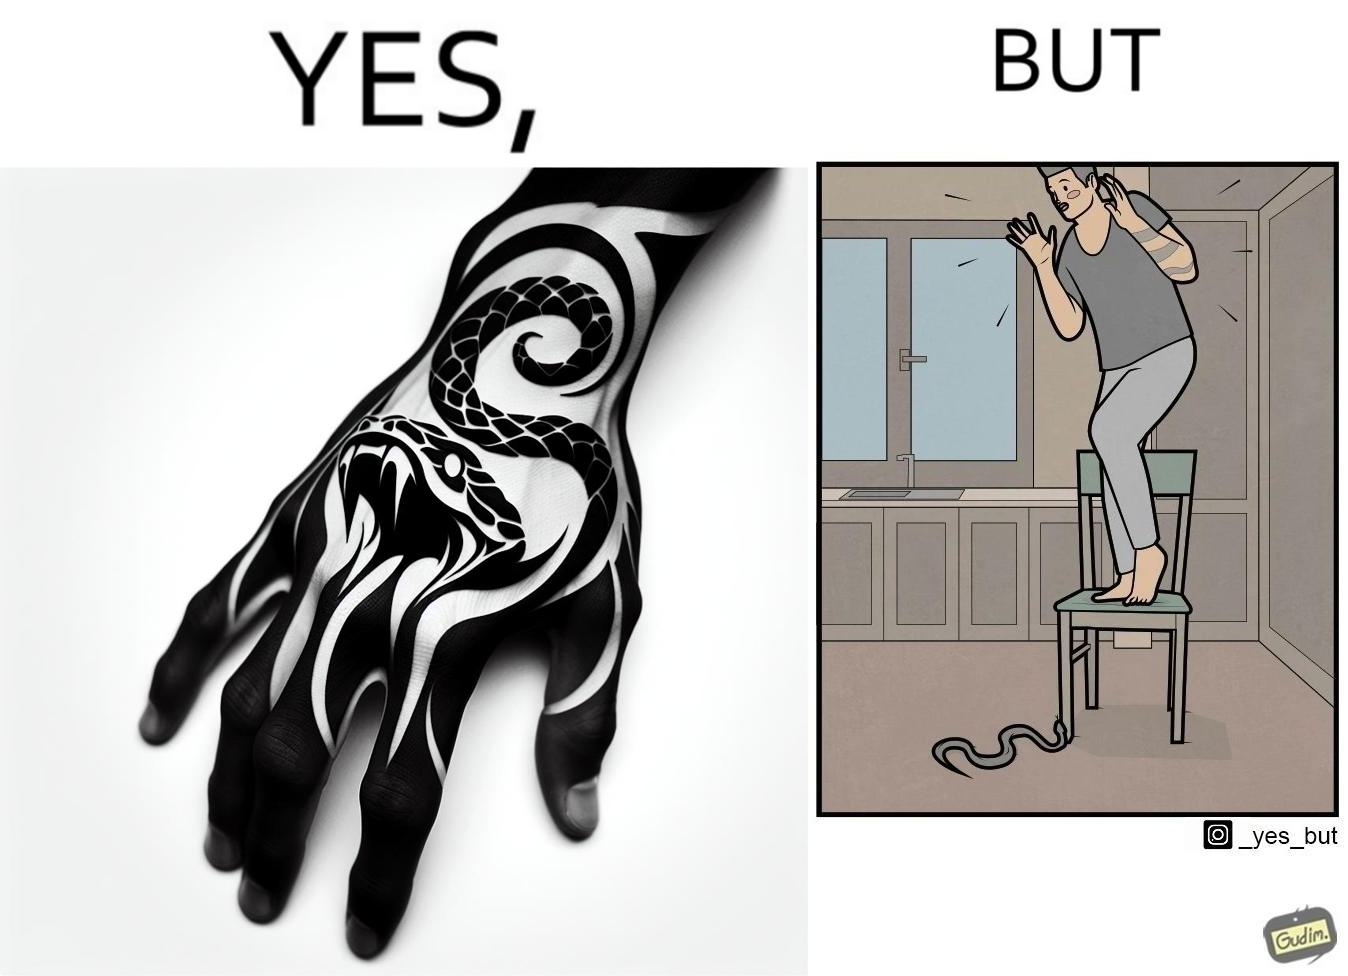What does this image depict? The image is ironic, because in the first image the tattoo of a snake on someone's hand may give us a hint about how powerful or brave the person can be who is having this tattoo but in the second image the person with same tattoo is seen frightened due to a snake in his house 